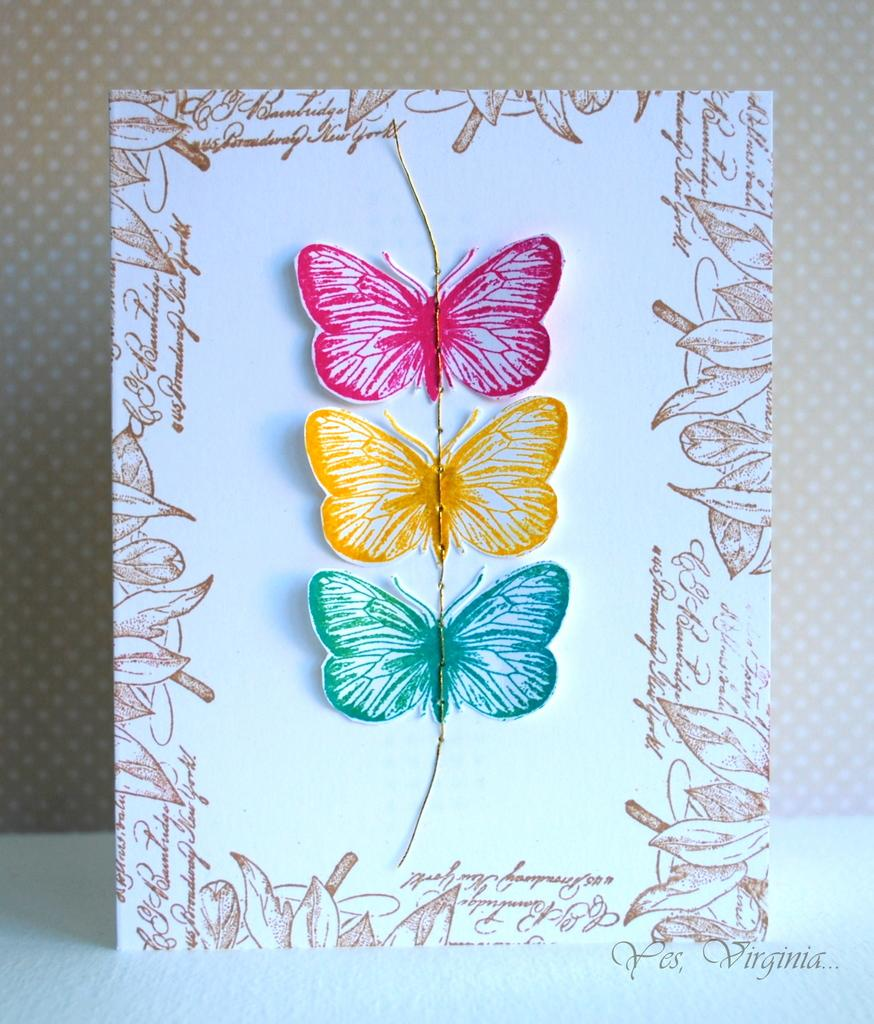What is the main subject of the image? The main subject of the image is a paper. What is depicted on the paper? There is a drawing on the paper. What can be seen behind the paper in the image? There is a wall behind the paper. What flavor of cream is being used in the drawing on the paper? There is no cream or flavor mentioned in the image, as it only features a drawing on a paper. 